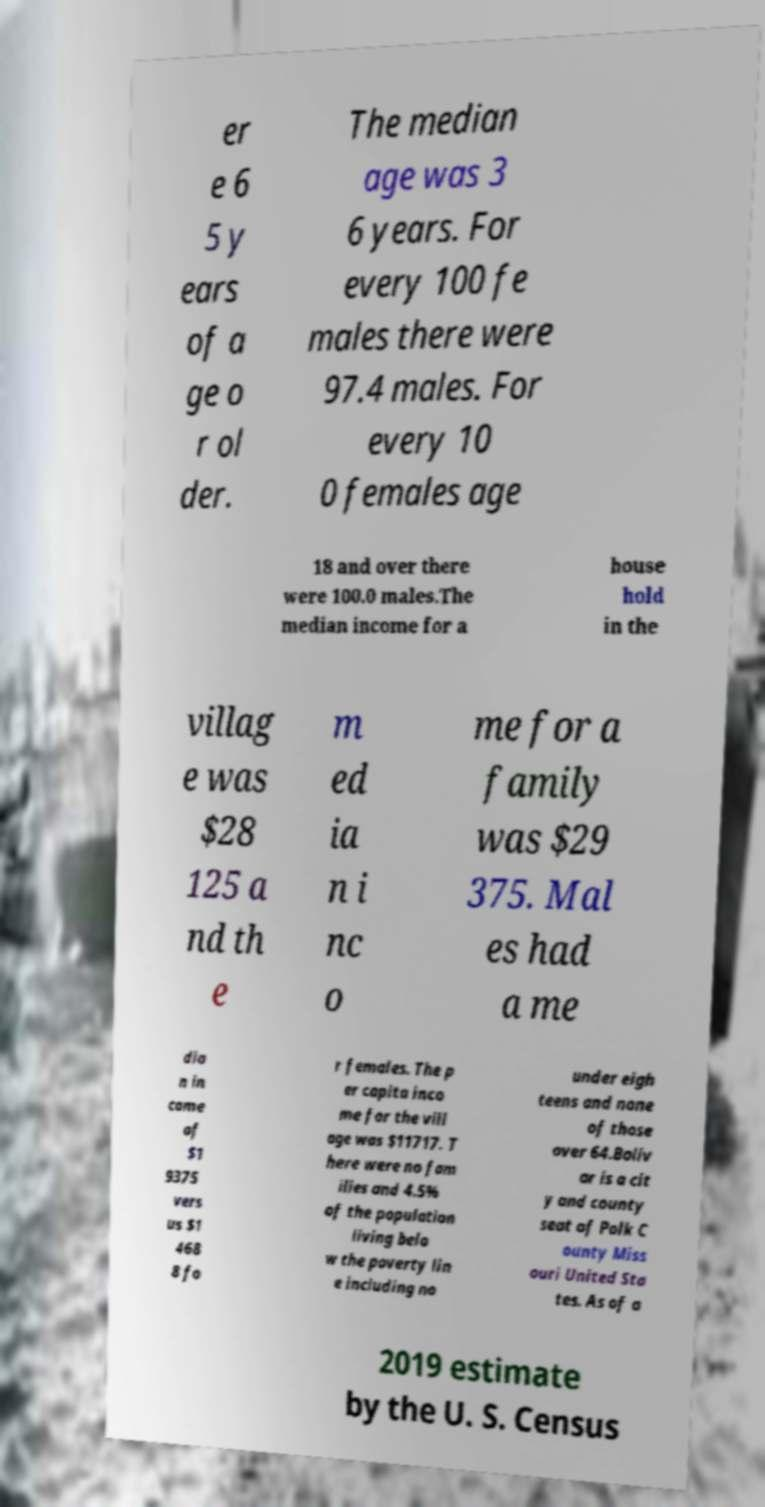I need the written content from this picture converted into text. Can you do that? er e 6 5 y ears of a ge o r ol der. The median age was 3 6 years. For every 100 fe males there were 97.4 males. For every 10 0 females age 18 and over there were 100.0 males.The median income for a house hold in the villag e was $28 125 a nd th e m ed ia n i nc o me for a family was $29 375. Mal es had a me dia n in come of $1 9375 vers us $1 468 8 fo r females. The p er capita inco me for the vill age was $11717. T here were no fam ilies and 4.5% of the population living belo w the poverty lin e including no under eigh teens and none of those over 64.Boliv ar is a cit y and county seat of Polk C ounty Miss ouri United Sta tes. As of a 2019 estimate by the U. S. Census 